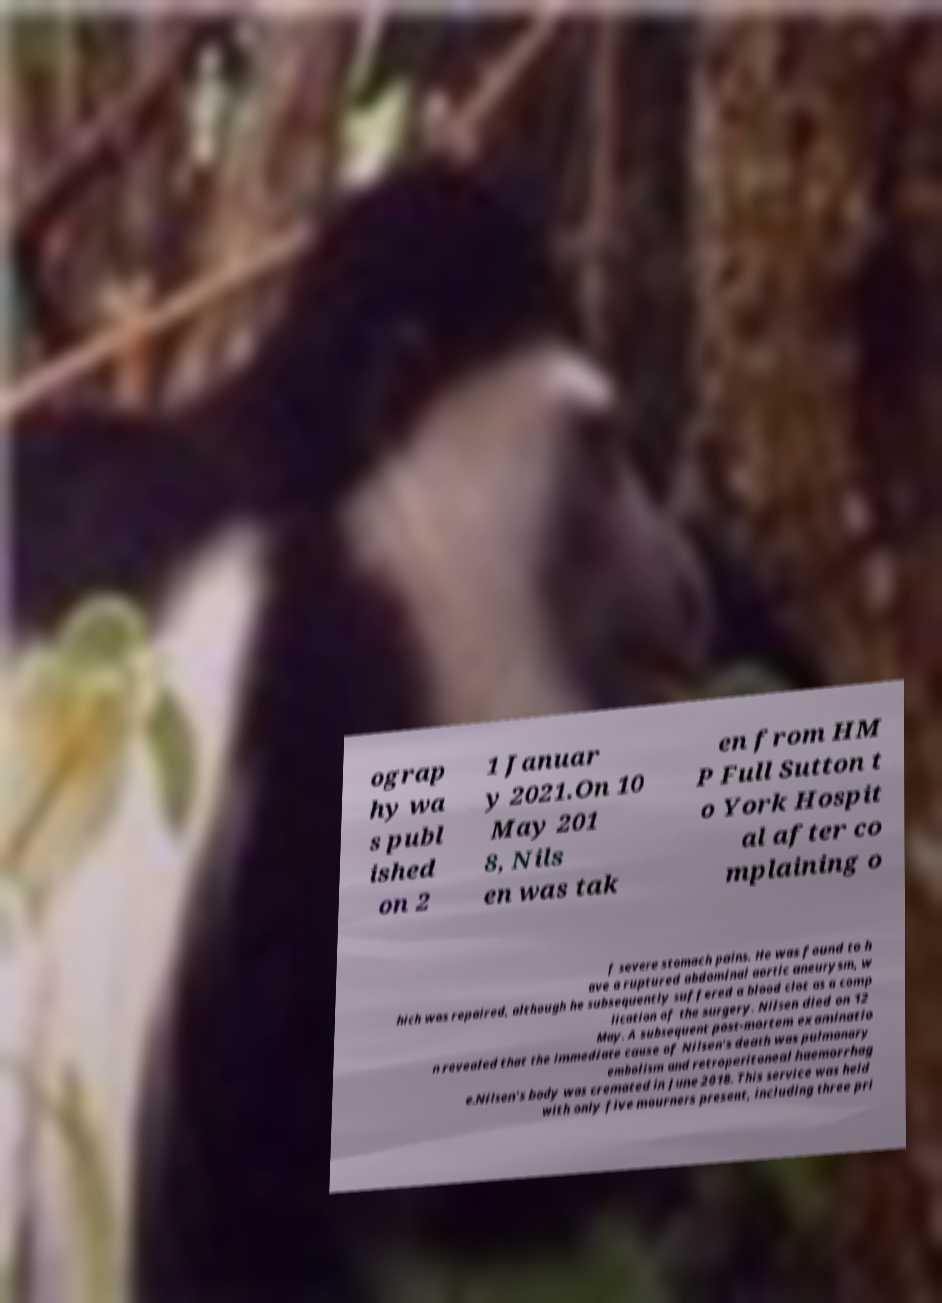For documentation purposes, I need the text within this image transcribed. Could you provide that? ograp hy wa s publ ished on 2 1 Januar y 2021.On 10 May 201 8, Nils en was tak en from HM P Full Sutton t o York Hospit al after co mplaining o f severe stomach pains. He was found to h ave a ruptured abdominal aortic aneurysm, w hich was repaired, although he subsequently suffered a blood clot as a comp lication of the surgery. Nilsen died on 12 May. A subsequent post-mortem examinatio n revealed that the immediate cause of Nilsen's death was pulmonary embolism and retroperitoneal haemorrhag e.Nilsen's body was cremated in June 2018. This service was held with only five mourners present, including three pri 